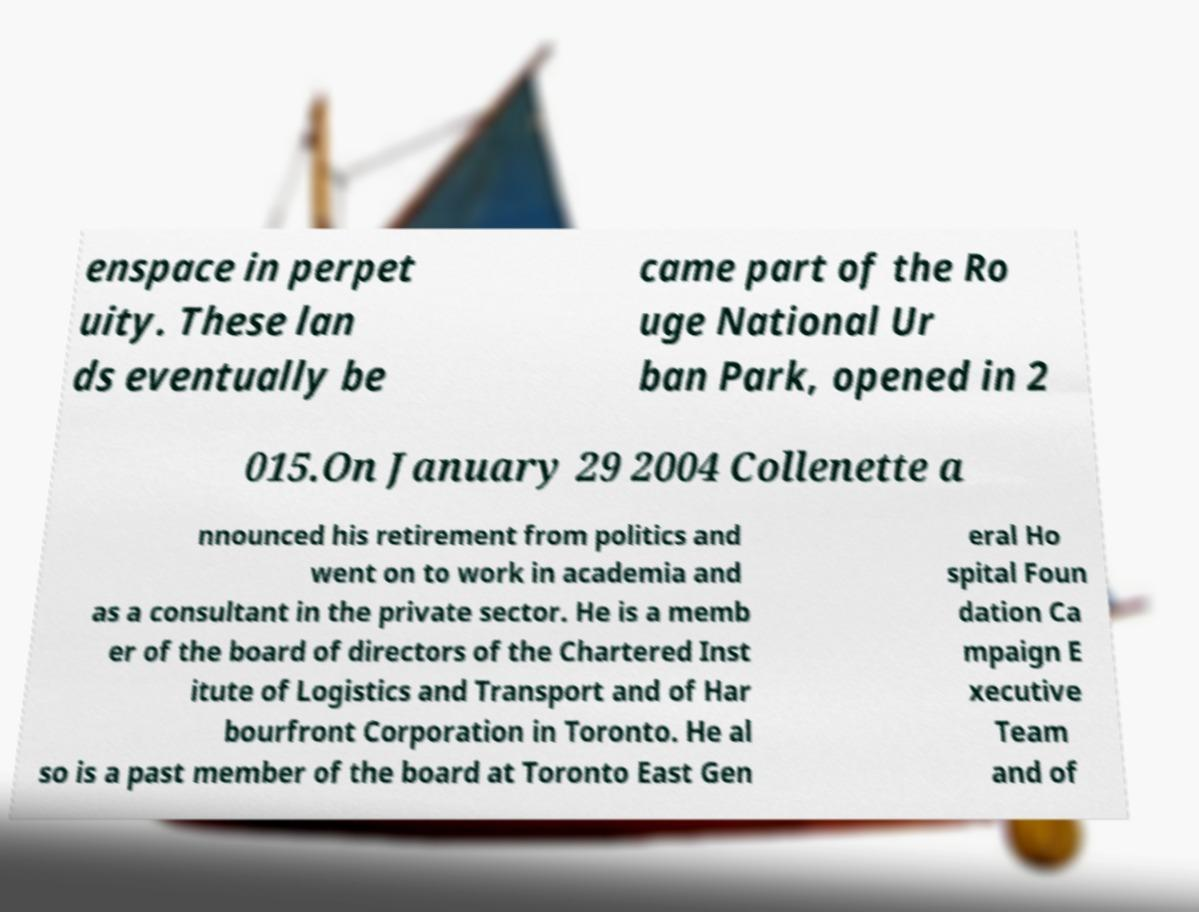Can you read and provide the text displayed in the image?This photo seems to have some interesting text. Can you extract and type it out for me? enspace in perpet uity. These lan ds eventually be came part of the Ro uge National Ur ban Park, opened in 2 015.On January 29 2004 Collenette a nnounced his retirement from politics and went on to work in academia and as a consultant in the private sector. He is a memb er of the board of directors of the Chartered Inst itute of Logistics and Transport and of Har bourfront Corporation in Toronto. He al so is a past member of the board at Toronto East Gen eral Ho spital Foun dation Ca mpaign E xecutive Team and of 